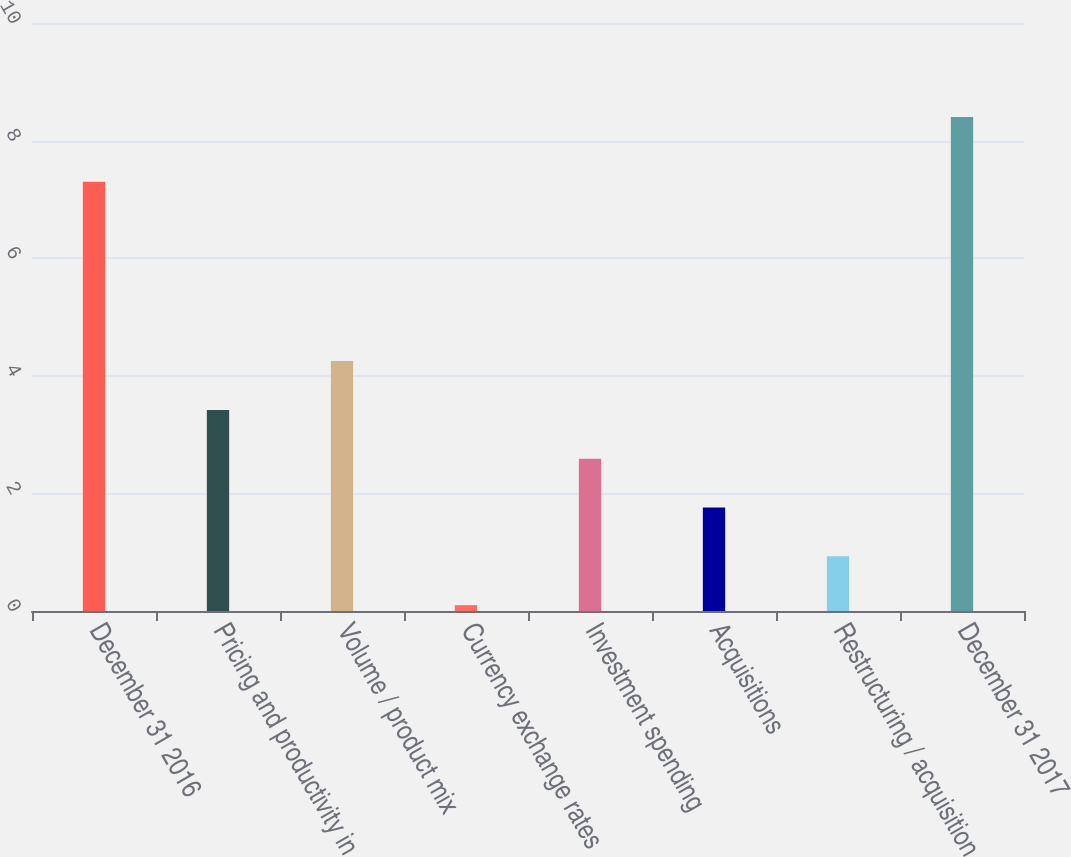Convert chart. <chart><loc_0><loc_0><loc_500><loc_500><bar_chart><fcel>December 31 2016<fcel>Pricing and productivity in<fcel>Volume / product mix<fcel>Currency exchange rates<fcel>Investment spending<fcel>Acquisitions<fcel>Restructuring / acquisition<fcel>December 31 2017<nl><fcel>7.3<fcel>3.42<fcel>4.25<fcel>0.1<fcel>2.59<fcel>1.76<fcel>0.93<fcel>8.4<nl></chart> 